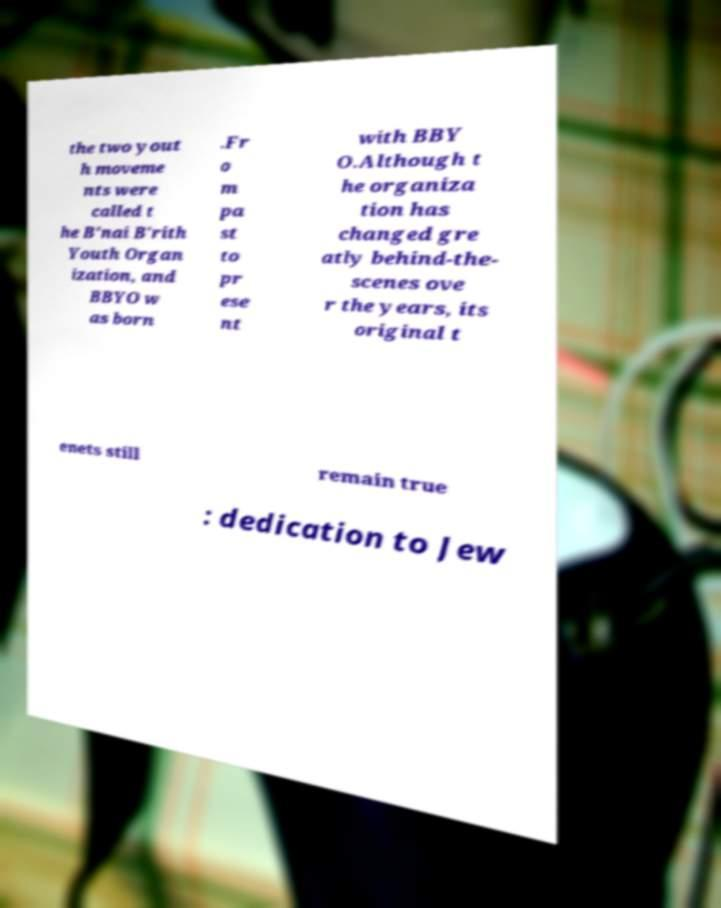I need the written content from this picture converted into text. Can you do that? the two yout h moveme nts were called t he B'nai B'rith Youth Organ ization, and BBYO w as born .Fr o m pa st to pr ese nt with BBY O.Although t he organiza tion has changed gre atly behind-the- scenes ove r the years, its original t enets still remain true : dedication to Jew 